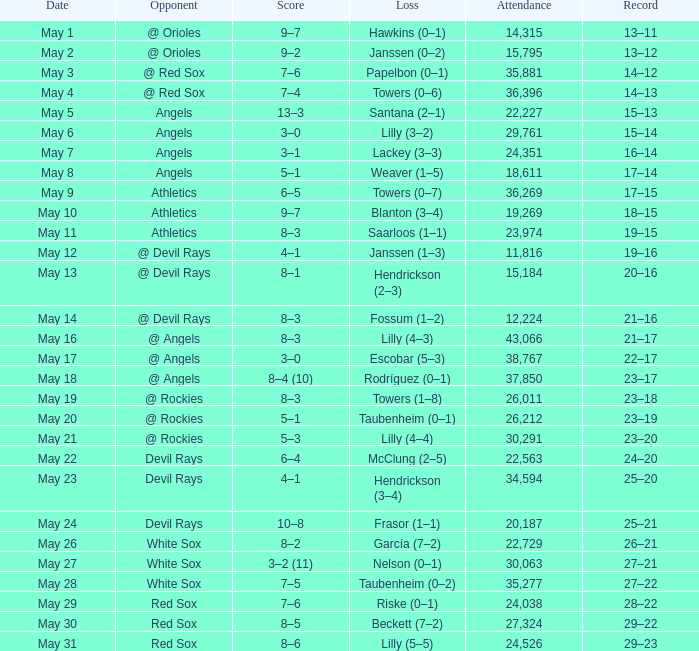When the team's record was 16 wins and 14 losses, what was the total number of attendees? 1.0. 